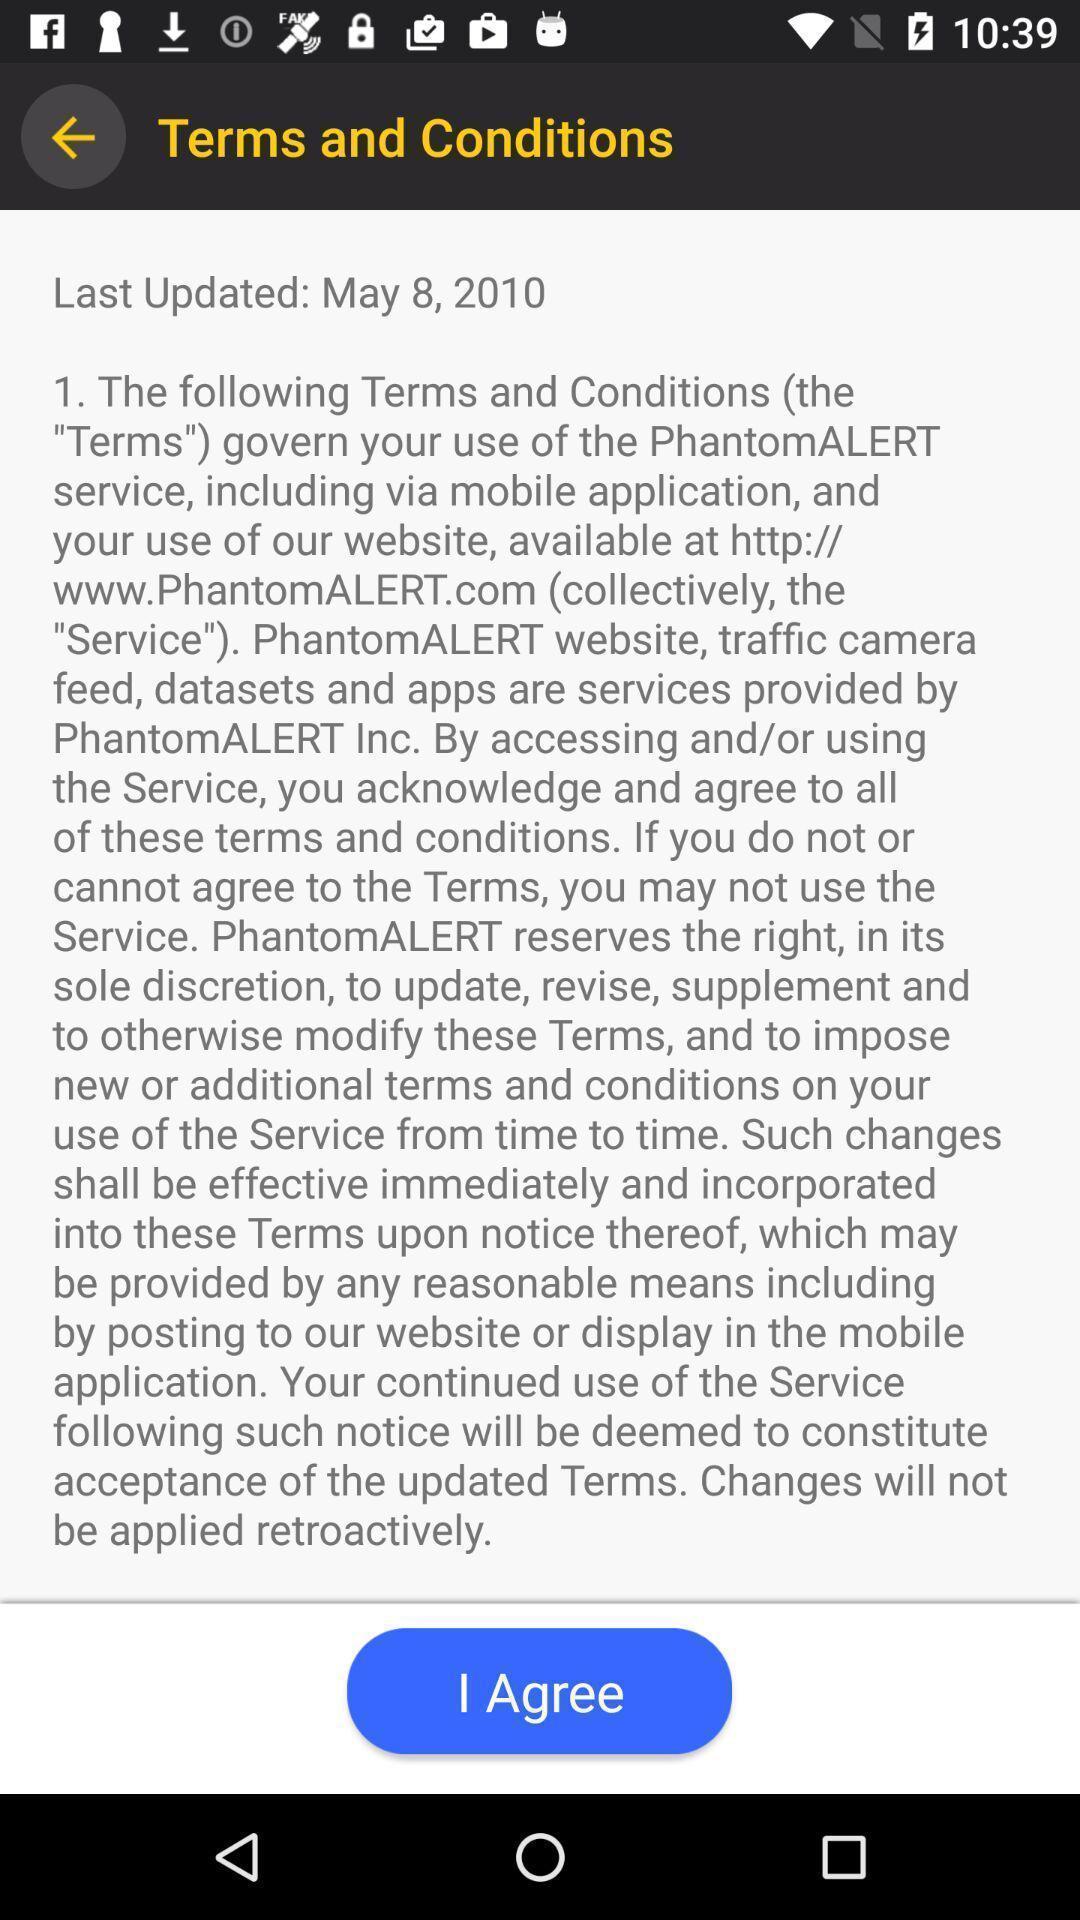Describe this image in words. Screen shows terms and conditions. 